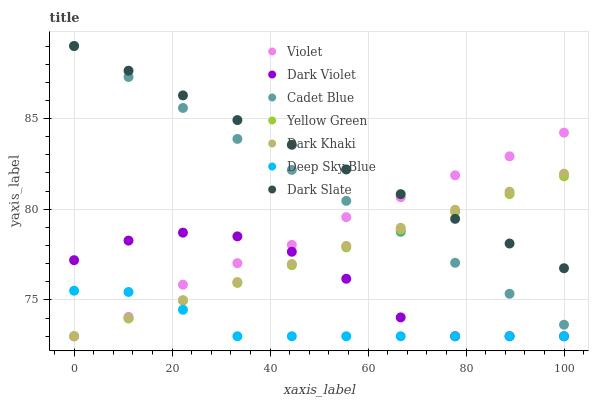Does Deep Sky Blue have the minimum area under the curve?
Answer yes or no. Yes. Does Dark Slate have the maximum area under the curve?
Answer yes or no. Yes. Does Yellow Green have the minimum area under the curve?
Answer yes or no. No. Does Yellow Green have the maximum area under the curve?
Answer yes or no. No. Is Dark Slate the smoothest?
Answer yes or no. Yes. Is Dark Violet the roughest?
Answer yes or no. Yes. Is Yellow Green the smoothest?
Answer yes or no. No. Is Yellow Green the roughest?
Answer yes or no. No. Does Yellow Green have the lowest value?
Answer yes or no. Yes. Does Dark Slate have the lowest value?
Answer yes or no. No. Does Dark Slate have the highest value?
Answer yes or no. Yes. Does Yellow Green have the highest value?
Answer yes or no. No. Is Deep Sky Blue less than Cadet Blue?
Answer yes or no. Yes. Is Dark Slate greater than Deep Sky Blue?
Answer yes or no. Yes. Does Violet intersect Dark Slate?
Answer yes or no. Yes. Is Violet less than Dark Slate?
Answer yes or no. No. Is Violet greater than Dark Slate?
Answer yes or no. No. Does Deep Sky Blue intersect Cadet Blue?
Answer yes or no. No. 